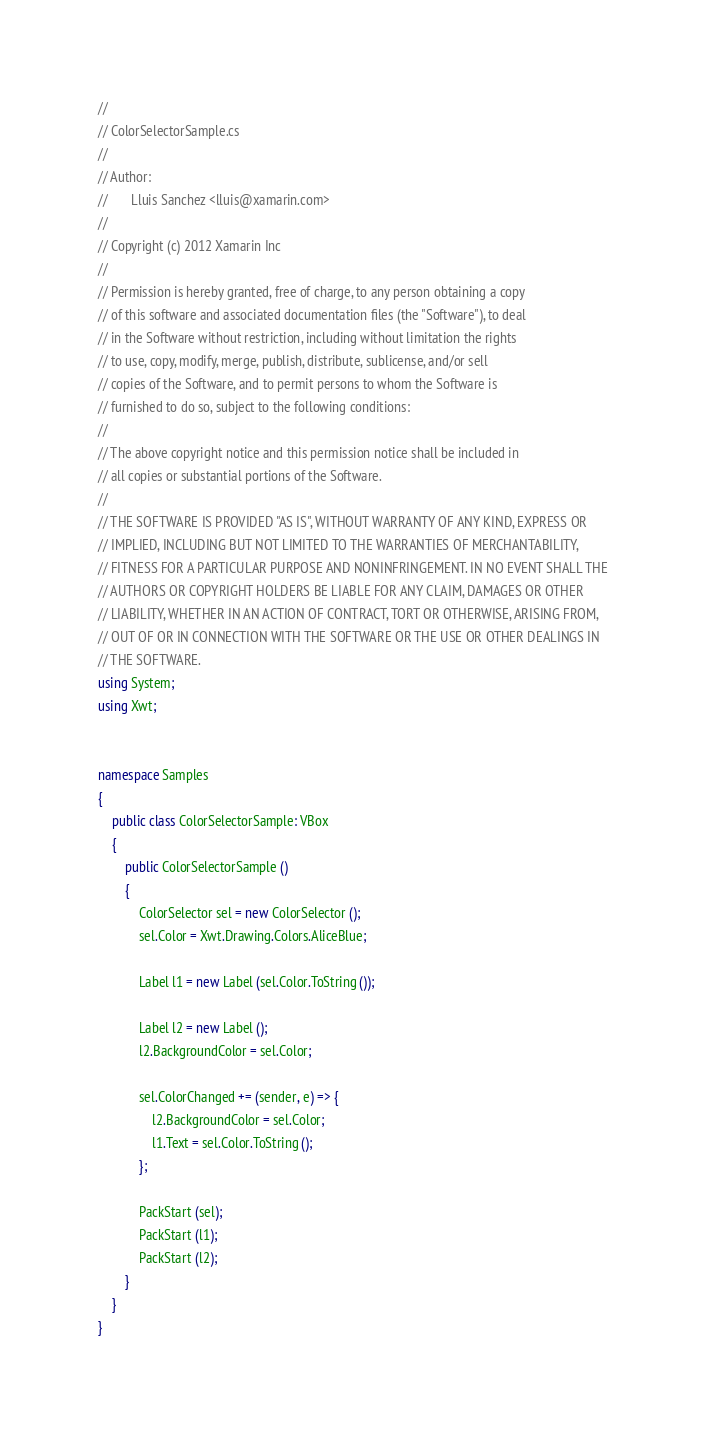<code> <loc_0><loc_0><loc_500><loc_500><_C#_>// 
// ColorSelectorSample.cs
//  
// Author:
//       Lluis Sanchez <lluis@xamarin.com>
// 
// Copyright (c) 2012 Xamarin Inc
// 
// Permission is hereby granted, free of charge, to any person obtaining a copy
// of this software and associated documentation files (the "Software"), to deal
// in the Software without restriction, including without limitation the rights
// to use, copy, modify, merge, publish, distribute, sublicense, and/or sell
// copies of the Software, and to permit persons to whom the Software is
// furnished to do so, subject to the following conditions:
// 
// The above copyright notice and this permission notice shall be included in
// all copies or substantial portions of the Software.
// 
// THE SOFTWARE IS PROVIDED "AS IS", WITHOUT WARRANTY OF ANY KIND, EXPRESS OR
// IMPLIED, INCLUDING BUT NOT LIMITED TO THE WARRANTIES OF MERCHANTABILITY,
// FITNESS FOR A PARTICULAR PURPOSE AND NONINFRINGEMENT. IN NO EVENT SHALL THE
// AUTHORS OR COPYRIGHT HOLDERS BE LIABLE FOR ANY CLAIM, DAMAGES OR OTHER
// LIABILITY, WHETHER IN AN ACTION OF CONTRACT, TORT OR OTHERWISE, ARISING FROM,
// OUT OF OR IN CONNECTION WITH THE SOFTWARE OR THE USE OR OTHER DEALINGS IN
// THE SOFTWARE.
using System;
using Xwt;


namespace Samples
{
	public class ColorSelectorSample: VBox
	{
		public ColorSelectorSample ()
		{
			ColorSelector sel = new ColorSelector ();
			sel.Color = Xwt.Drawing.Colors.AliceBlue;

			Label l1 = new Label (sel.Color.ToString ());

			Label l2 = new Label ();
			l2.BackgroundColor = sel.Color;

			sel.ColorChanged += (sender, e) => {
				l2.BackgroundColor = sel.Color;
				l1.Text = sel.Color.ToString ();
			};

			PackStart (sel);
			PackStart (l1);
			PackStart (l2);
		}
	}
}

</code> 